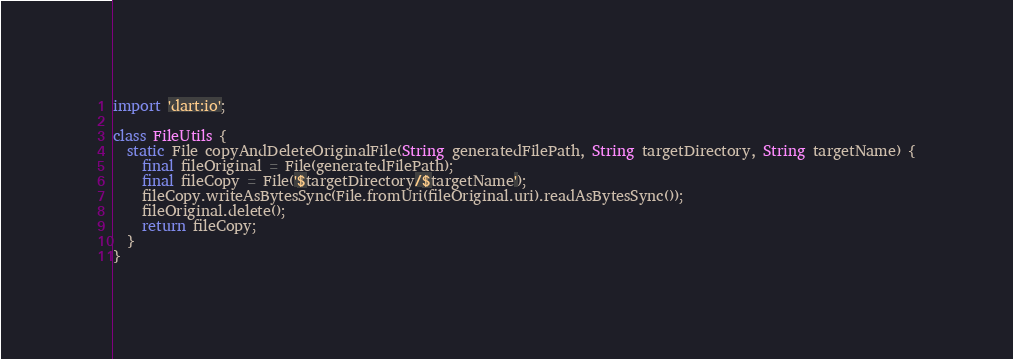<code> <loc_0><loc_0><loc_500><loc_500><_Dart_>import 'dart:io';

class FileUtils {
  static File copyAndDeleteOriginalFile(String generatedFilePath, String targetDirectory, String targetName) {
    final fileOriginal = File(generatedFilePath);
    final fileCopy = File('$targetDirectory/$targetName');
    fileCopy.writeAsBytesSync(File.fromUri(fileOriginal.uri).readAsBytesSync());
    fileOriginal.delete();
    return fileCopy;
  }
}
</code> 